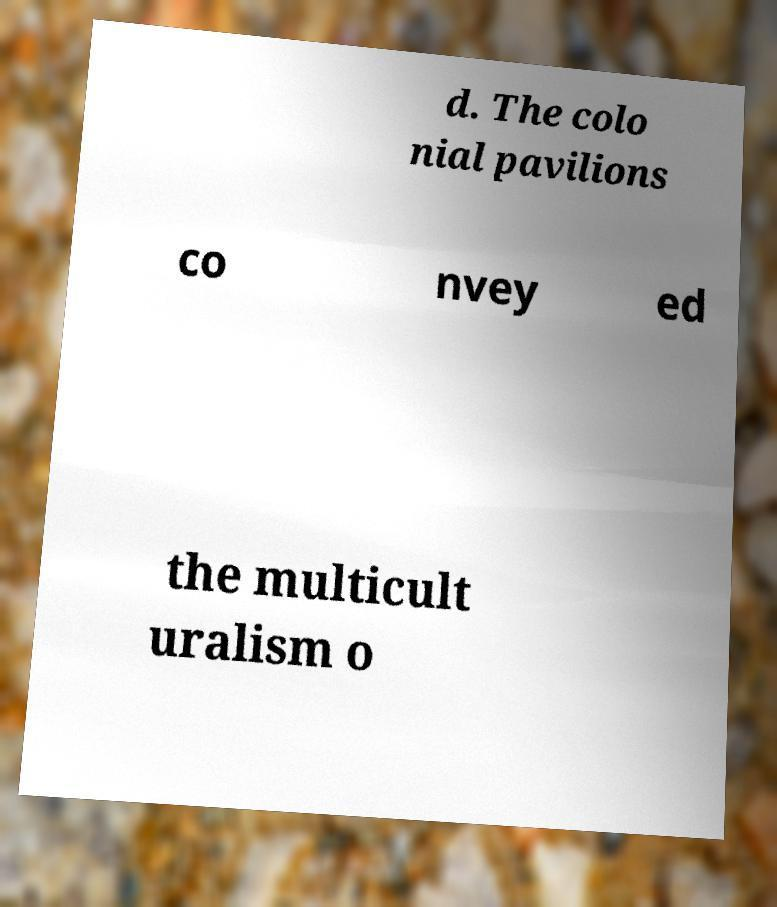What messages or text are displayed in this image? I need them in a readable, typed format. d. The colo nial pavilions co nvey ed the multicult uralism o 